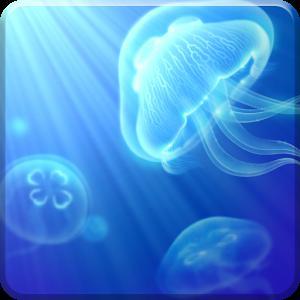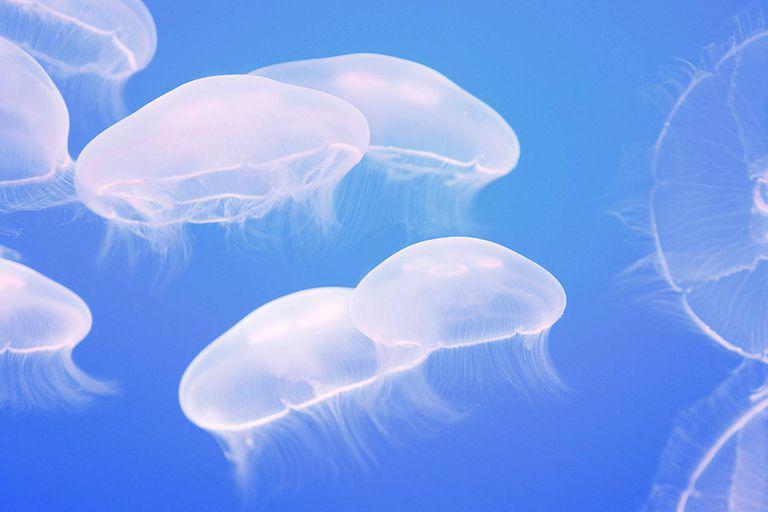The first image is the image on the left, the second image is the image on the right. Evaluate the accuracy of this statement regarding the images: "there are two jellyfish in the image pair". Is it true? Answer yes or no. No. 